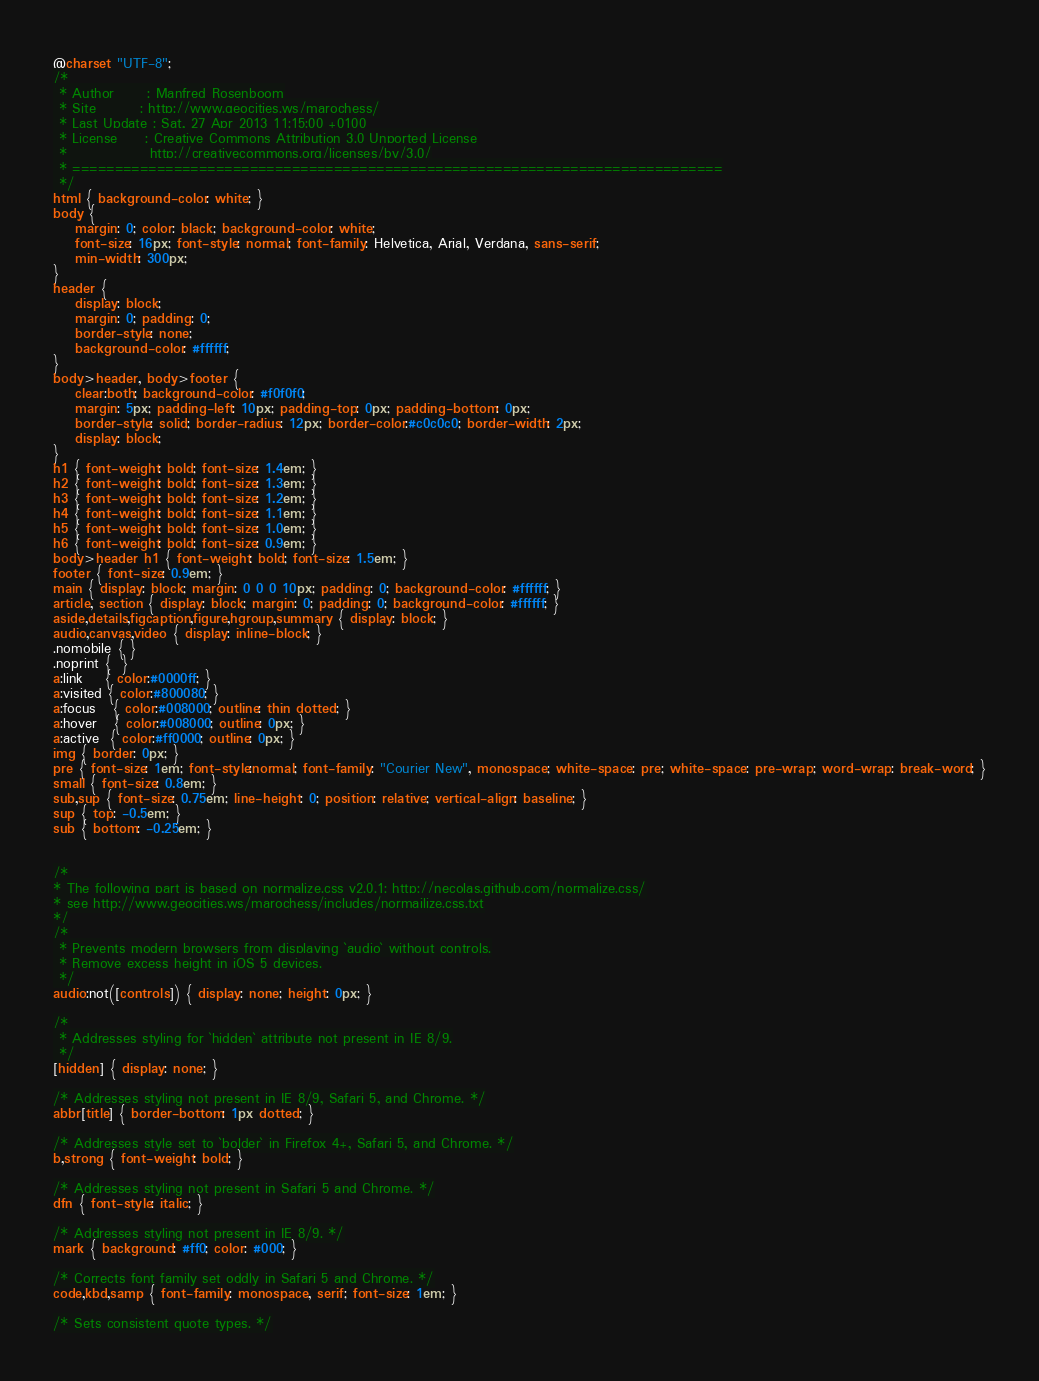<code> <loc_0><loc_0><loc_500><loc_500><_CSS_>@charset "UTF-8";
/*
 * Author      : Manfred Rosenboom
 * Site        : http://www.geocities.ws/marochess/
 * Last Update : Sat, 27 Apr 2013 11:15:00 +0100
 * License     : Creative Commons Attribution 3.0 Unported License
 *               http://creativecommons.org/licenses/by/3.0/
 * =============================================================================
 */
html { background-color: white; }
body { 
    margin: 0; color: black; background-color: white; 
    font-size: 16px; font-style: normal; font-family: Helvetica, Arial, Verdana, sans-serif;
    min-width: 300px;
}
header {
    display: block;
    margin: 0; padding: 0;
    border-style: none;
    background-color: #ffffff;
}
body>header, body>footer {
    clear:both; background-color: #f0f0f0;
    margin: 5px; padding-left: 10px; padding-top: 0px; padding-bottom: 0px;
    border-style: solid; border-radius: 12px; border-color:#c0c0c0; border-width: 2px;
    display: block;
}
h1 { font-weight: bold; font-size: 1.4em; }
h2 { font-weight: bold; font-size: 1.3em; }
h3 { font-weight: bold; font-size: 1.2em; }
h4 { font-weight: bold; font-size: 1.1em; }
h5 { font-weight: bold; font-size: 1.0em; }
h6 { font-weight: bold; font-size: 0.9em; }
body>header h1 { font-weight: bold; font-size: 1.5em; }
footer { font-size: 0.9em; }
main { display: block; margin: 0 0 0 10px; padding: 0; background-color: #ffffff; }
article, section { display: block; margin: 0; padding: 0; background-color: #ffffff; }
aside,details,figcaption,figure,hgroup,summary { display: block; }
audio,canvas,video { display: inline-block; }
.nomobile { }
.noprint {  }
a:link    { color:#0000ff; }
a:visited { color:#800080; }
a:focus   { color:#008000; outline: thin dotted; }
a:hover   { color:#008000; outline: 0px; }
a:active  { color:#ff0000; outline: 0px; }
img { border: 0px; }
pre { font-size: 1em; font-style:normal; font-family: "Courier New", monospace; white-space: pre; white-space: pre-wrap; word-wrap: break-word; }
small { font-size: 0.8em; }
sub,sup { font-size: 0.75em; line-height: 0; position: relative; vertical-align: baseline; }
sup { top: -0.5em; }
sub { bottom: -0.25em; }


/*
* The following part is based on normalize.css v2.0.1: http://necolas.github.com/normalize.css/
* see http://www.geocities.ws/marochess/includes/normailize.css.txt
*/
/*
 * Prevents modern browsers from displaying `audio` without controls.
 * Remove excess height in iOS 5 devices.
 */
audio:not([controls]) { display: none; height: 0px; }

/*
 * Addresses styling for `hidden` attribute not present in IE 8/9.
 */
[hidden] { display: none; }

/* Addresses styling not present in IE 8/9, Safari 5, and Chrome. */
abbr[title] { border-bottom: 1px dotted; }

/* Addresses style set to `bolder` in Firefox 4+, Safari 5, and Chrome. */
b,strong { font-weight: bold; }

/* Addresses styling not present in Safari 5 and Chrome. */
dfn { font-style: italic; }

/* Addresses styling not present in IE 8/9. */
mark { background: #ff0; color: #000; }

/* Corrects font family set oddly in Safari 5 and Chrome. */
code,kbd,samp { font-family: monospace, serif; font-size: 1em; }

/* Sets consistent quote types. */</code> 